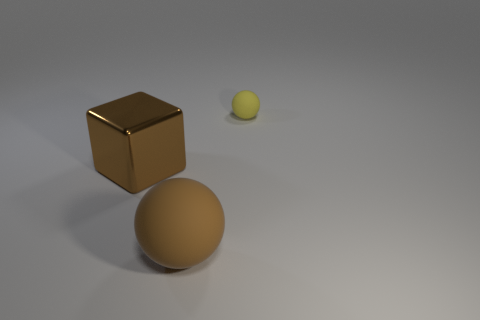What is the material of the sphere that is in front of the tiny yellow sphere?
Offer a very short reply. Rubber. There is a matte ball that is behind the large metallic block; what number of brown metal cubes are to the left of it?
Offer a terse response. 1. How many other yellow things have the same shape as the metal thing?
Offer a terse response. 0. What number of tiny purple shiny cylinders are there?
Provide a short and direct response. 0. What is the color of the thing that is to the right of the large matte object?
Ensure brevity in your answer.  Yellow. What color is the ball in front of the matte ball behind the cube?
Make the answer very short. Brown. There is a matte object that is the same size as the shiny thing; what color is it?
Ensure brevity in your answer.  Brown. What number of large brown objects are right of the brown metal cube and behind the brown matte object?
Provide a short and direct response. 0. There is a big metallic thing that is the same color as the big matte thing; what shape is it?
Provide a short and direct response. Cube. What material is the object that is behind the big brown rubber ball and to the left of the small matte ball?
Your response must be concise. Metal. 